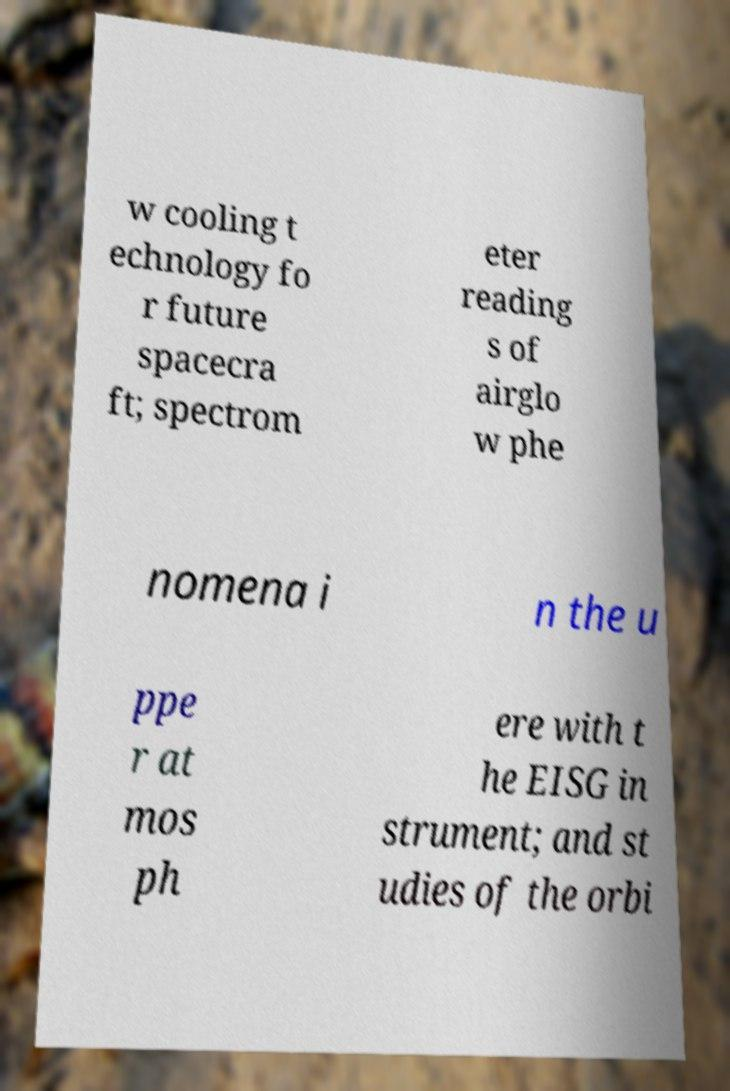What messages or text are displayed in this image? I need them in a readable, typed format. w cooling t echnology fo r future spacecra ft; spectrom eter reading s of airglo w phe nomena i n the u ppe r at mos ph ere with t he EISG in strument; and st udies of the orbi 